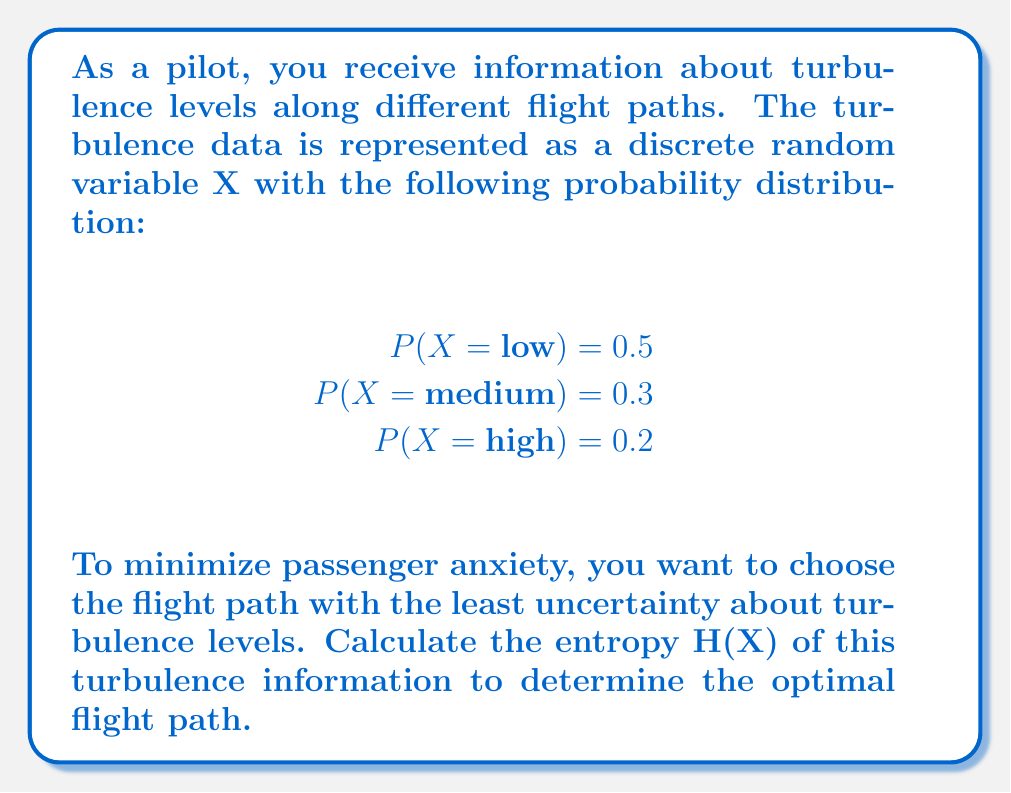Teach me how to tackle this problem. To solve this problem, we'll use the concept of entropy from information theory. Entropy measures the average amount of information or uncertainty in a random variable. For a discrete random variable X, the entropy H(X) is given by:

$$H(X) = -\sum_{i} P(X = x_i) \log_2 P(X = x_i)$$

where $P(X = x_i)$ is the probability of each possible outcome.

Let's calculate the entropy step by step:

1) For X = low:
   $-P(X = \text{low}) \log_2 P(X = \text{low}) = -0.5 \log_2 0.5 = 0.5$

2) For X = medium:
   $-P(X = \text{medium}) \log_2 P(X = \text{medium}) = -0.3 \log_2 0.3 \approx 0.521$

3) For X = high:
   $-P(X = \text{high}) \log_2 P(X = \text{high}) = -0.2 \log_2 0.2 \approx 0.464$

4) Sum up all the terms:
   $H(X) = 0.5 + 0.521 + 0.464 = 1.485$ bits

This entropy value represents the average amount of information needed to describe the turbulence levels along this flight path. A lower entropy would indicate less uncertainty and thus a more predictable (and potentially less anxiety-inducing) flight path.
Answer: The entropy H(X) of the turbulence information is approximately 1.485 bits. 